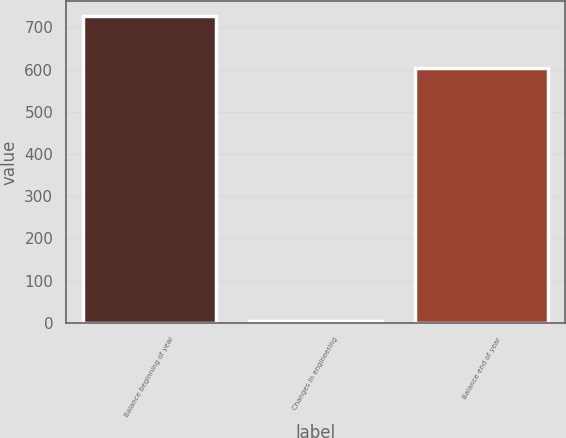Convert chart. <chart><loc_0><loc_0><loc_500><loc_500><bar_chart><fcel>Balance beginning of year<fcel>Changes in engineering<fcel>Balance end of year<nl><fcel>726<fcel>5<fcel>603<nl></chart> 